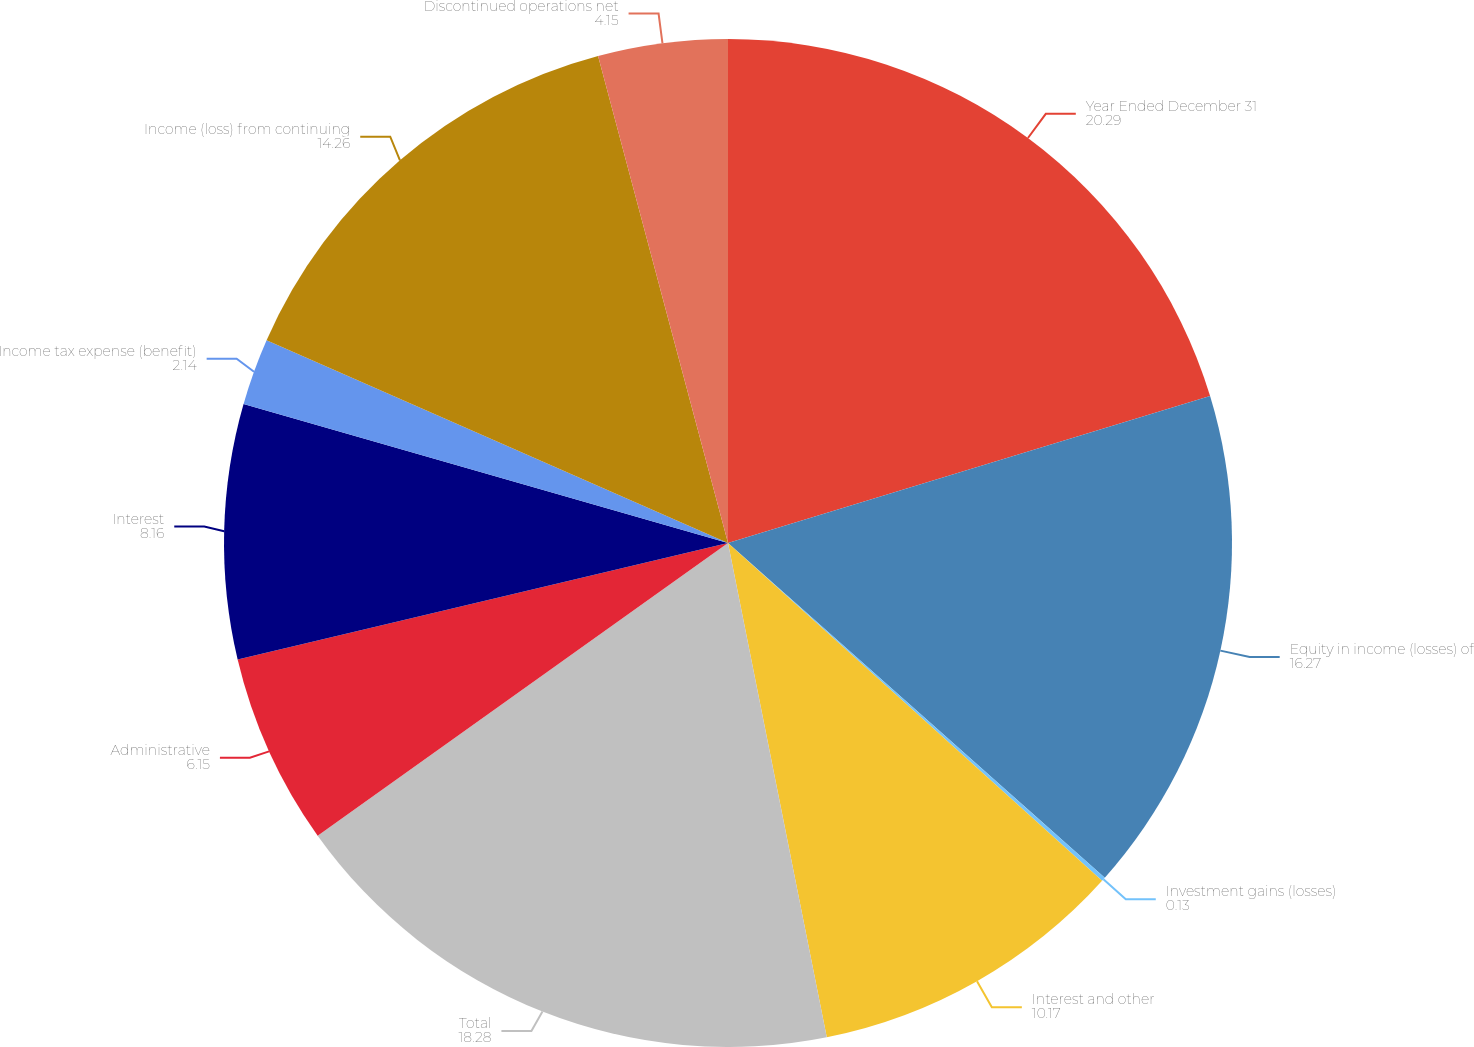<chart> <loc_0><loc_0><loc_500><loc_500><pie_chart><fcel>Year Ended December 31<fcel>Equity in income (losses) of<fcel>Investment gains (losses)<fcel>Interest and other<fcel>Total<fcel>Administrative<fcel>Interest<fcel>Income tax expense (benefit)<fcel>Income (loss) from continuing<fcel>Discontinued operations net<nl><fcel>20.29%<fcel>16.27%<fcel>0.13%<fcel>10.17%<fcel>18.28%<fcel>6.15%<fcel>8.16%<fcel>2.14%<fcel>14.26%<fcel>4.15%<nl></chart> 